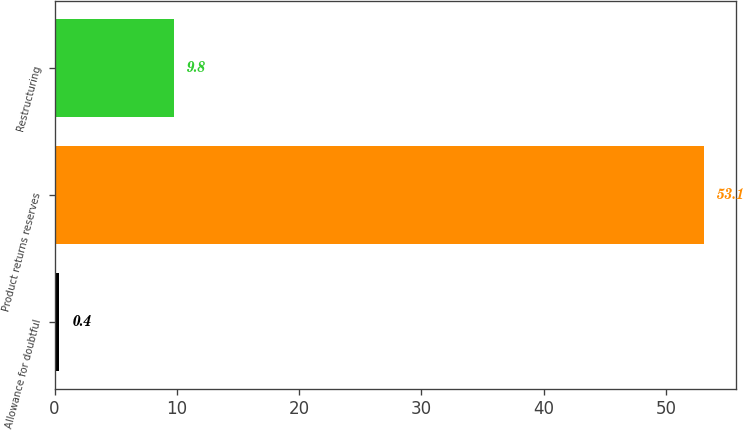Convert chart to OTSL. <chart><loc_0><loc_0><loc_500><loc_500><bar_chart><fcel>Allowance for doubtful<fcel>Product returns reserves<fcel>Restructuring<nl><fcel>0.4<fcel>53.1<fcel>9.8<nl></chart> 